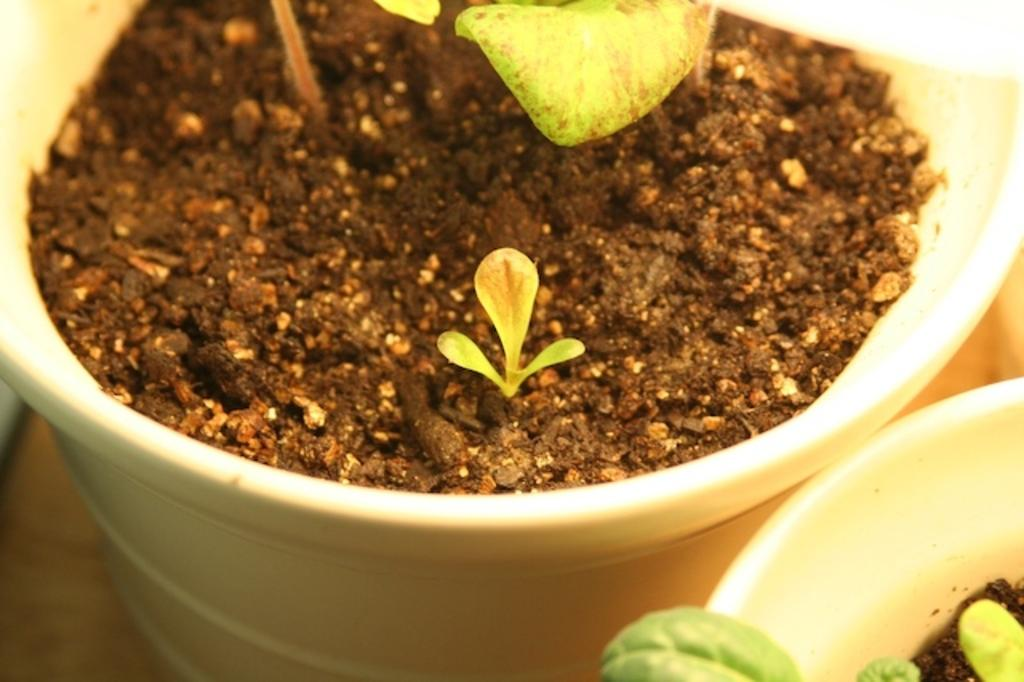What can be seen in the pots in the image? There are mud and plants in the pots in the image. Where are the pots located? The pots are on a surface that resembles a floor in the image. What else is visible on the left side of the image? There is an object on the left side of the image. Can you describe the father's teeth in the image? There is no father or teeth present in the image; it features two pots with mud and plants on a surface that resembles a floor. 